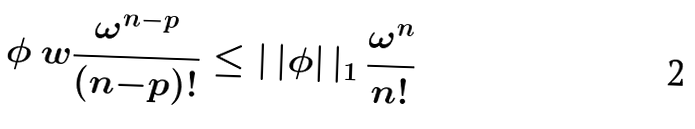<formula> <loc_0><loc_0><loc_500><loc_500>\phi \ w \frac { \omega ^ { n - p } } { ( n { - } p ) ! } \leq | \, | \phi | \, | _ { 1 } \, \frac { \omega ^ { n } } { n ! }</formula> 